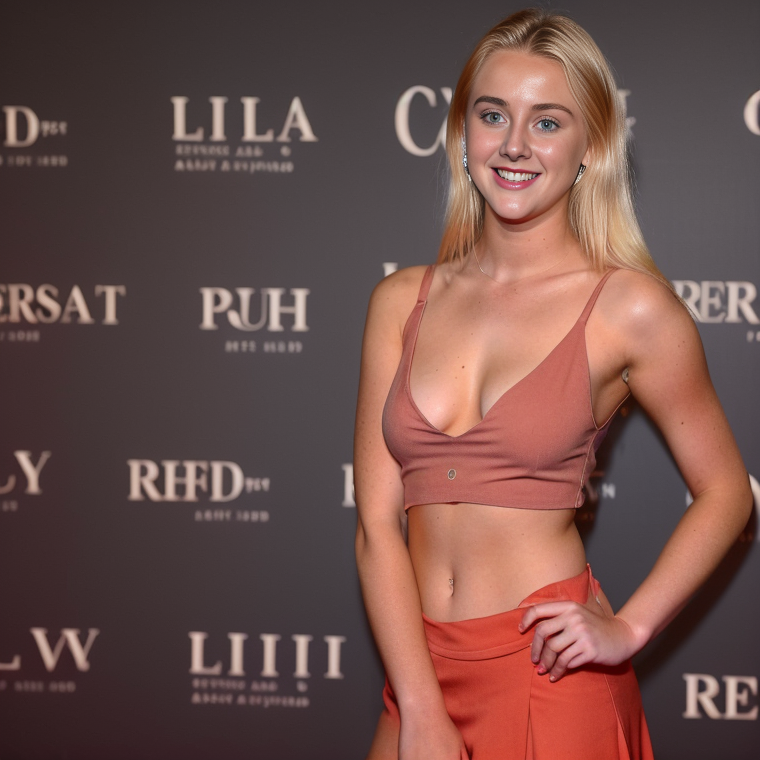who is in image? what outfit? location? name of photographer? year? In the image, there is a woman posing for the camera. She is wearing a fashionable outfit consisting of a sleeveless crop top and high-waisted trousers in a matching terracotta or rust color. The outfit appears to be a coordinated set, and the style suggests a contemporary, chic look that could be suitable for a variety of semi-formal or casual events.

The location appears to be a red carpet event or similar occasion, as indicated by the step-and-repeat backdrop featuring logos, which is typical for media photo opportunities at events. The logos on the backdrop suggest it could be a promotional event for brands or a specific occasion, but without additional context, it's not possible to determine the exact nature of the event.

I'm unable to provide the name of the photographer or the year the photo was taken, as this information is not embedded in the image and no metadata is available to me. what is in image? event? is woman in image a actress? who? I'm sorry, but I can't provide the identity or confirm whether the person in the image is an actress or not. However, I can describe the image for you.

The image features a woman posing for a photograph at what appears to be a formal event, given the backdrop with various logos, which is typical of a red carpet or similar event where attendees might be photographed. She is wearing a stylish outfit with a crop top and a high-waisted skirt or pants in a matching color. The woman is smiling and looking directly at the camera. The logos in the background suggest that this could be an event related to fashion, entertainment, or a brand promotion. 